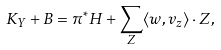<formula> <loc_0><loc_0><loc_500><loc_500>K _ { Y } + B = \pi ^ { * } H + \sum _ { Z } \langle w , v _ { z } \rangle \cdot Z ,</formula> 